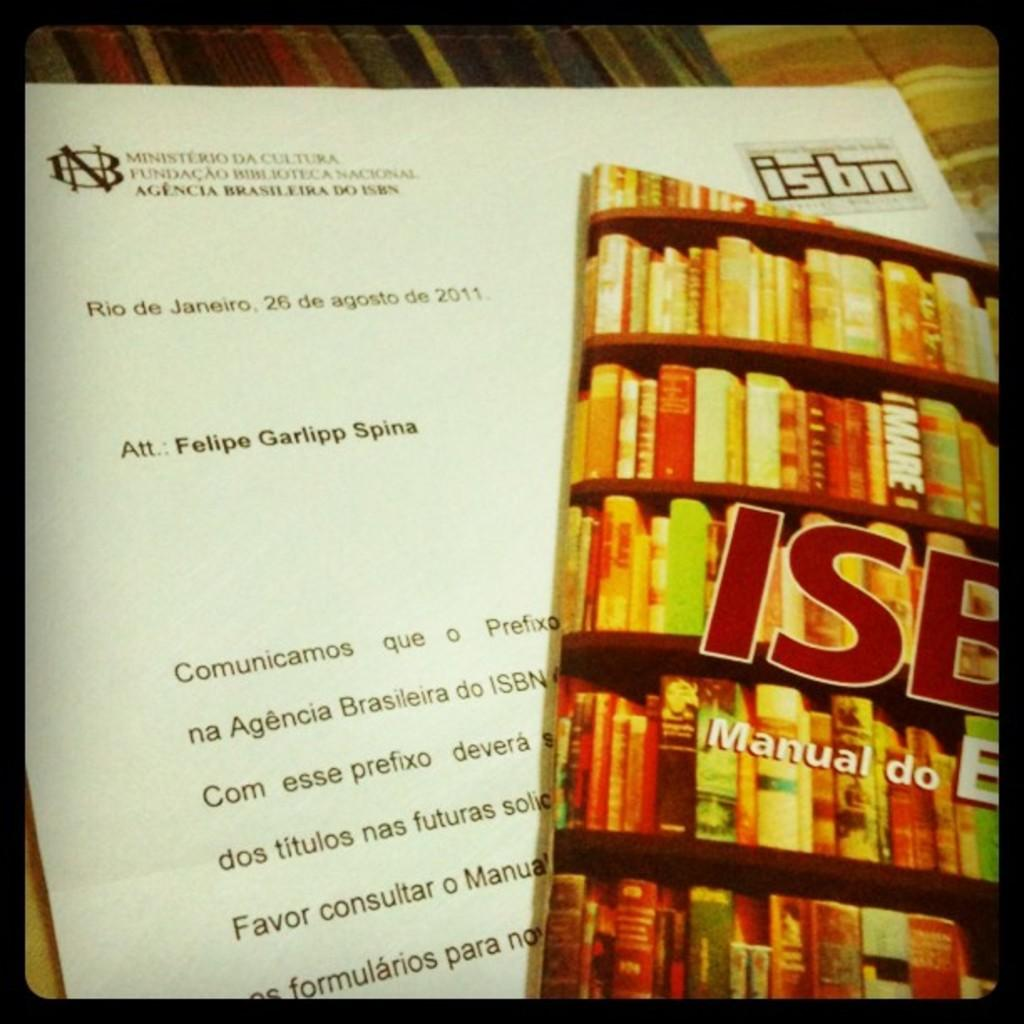<image>
Share a concise interpretation of the image provided. A letter to Felipe Garlipp Spina has a magazine laying on it. 